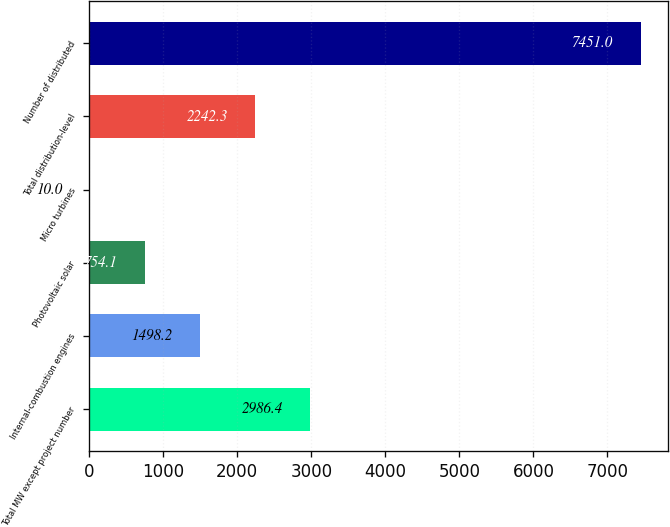<chart> <loc_0><loc_0><loc_500><loc_500><bar_chart><fcel>Total MW except project number<fcel>Internal-combustion engines<fcel>Photovoltaic solar<fcel>Micro turbines<fcel>Total distribution-level<fcel>Number of distributed<nl><fcel>2986.4<fcel>1498.2<fcel>754.1<fcel>10<fcel>2242.3<fcel>7451<nl></chart> 